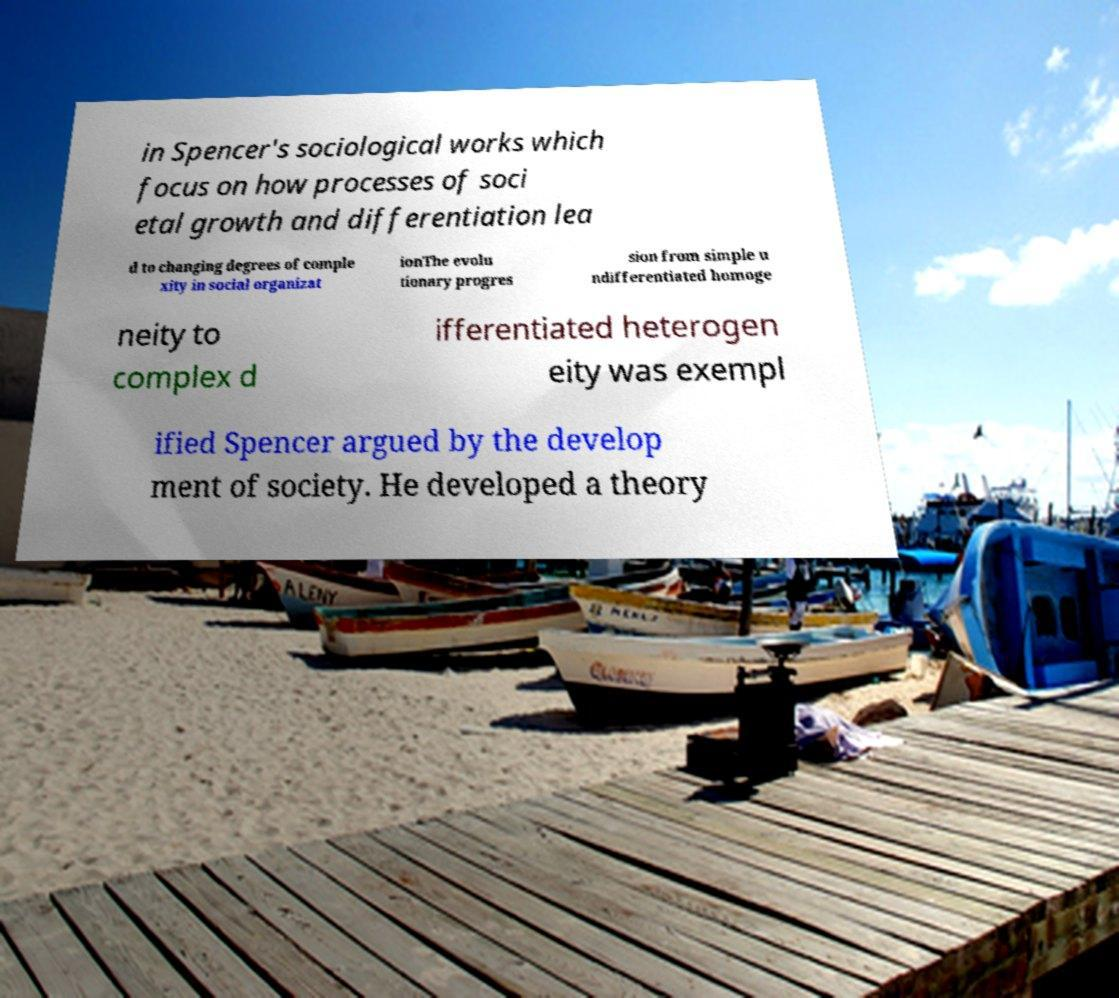I need the written content from this picture converted into text. Can you do that? in Spencer's sociological works which focus on how processes of soci etal growth and differentiation lea d to changing degrees of comple xity in social organizat ionThe evolu tionary progres sion from simple u ndifferentiated homoge neity to complex d ifferentiated heterogen eity was exempl ified Spencer argued by the develop ment of society. He developed a theory 